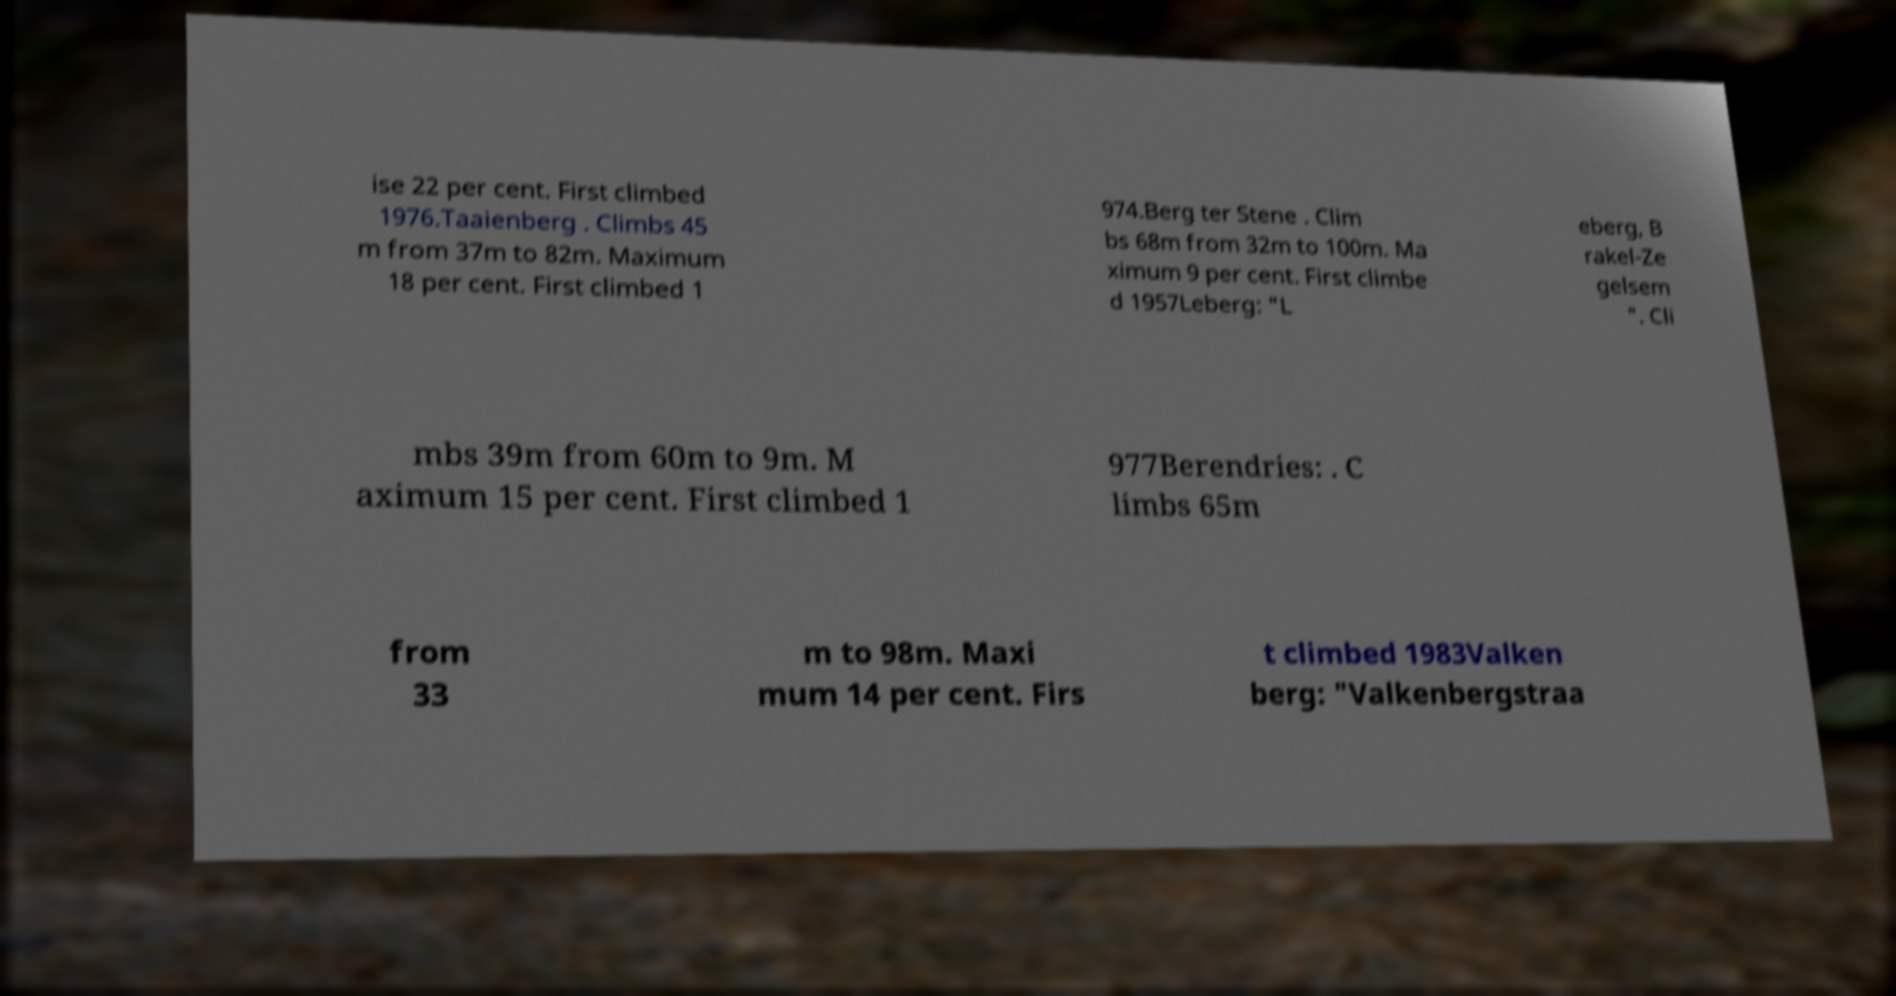Please read and relay the text visible in this image. What does it say? ise 22 per cent. First climbed 1976.Taaienberg . Climbs 45 m from 37m to 82m. Maximum 18 per cent. First climbed 1 974.Berg ter Stene . Clim bs 68m from 32m to 100m. Ma ximum 9 per cent. First climbe d 1957Leberg: "L eberg, B rakel-Ze gelsem ". Cli mbs 39m from 60m to 9m. M aximum 15 per cent. First climbed 1 977Berendries: . C limbs 65m from 33 m to 98m. Maxi mum 14 per cent. Firs t climbed 1983Valken berg: "Valkenbergstraa 